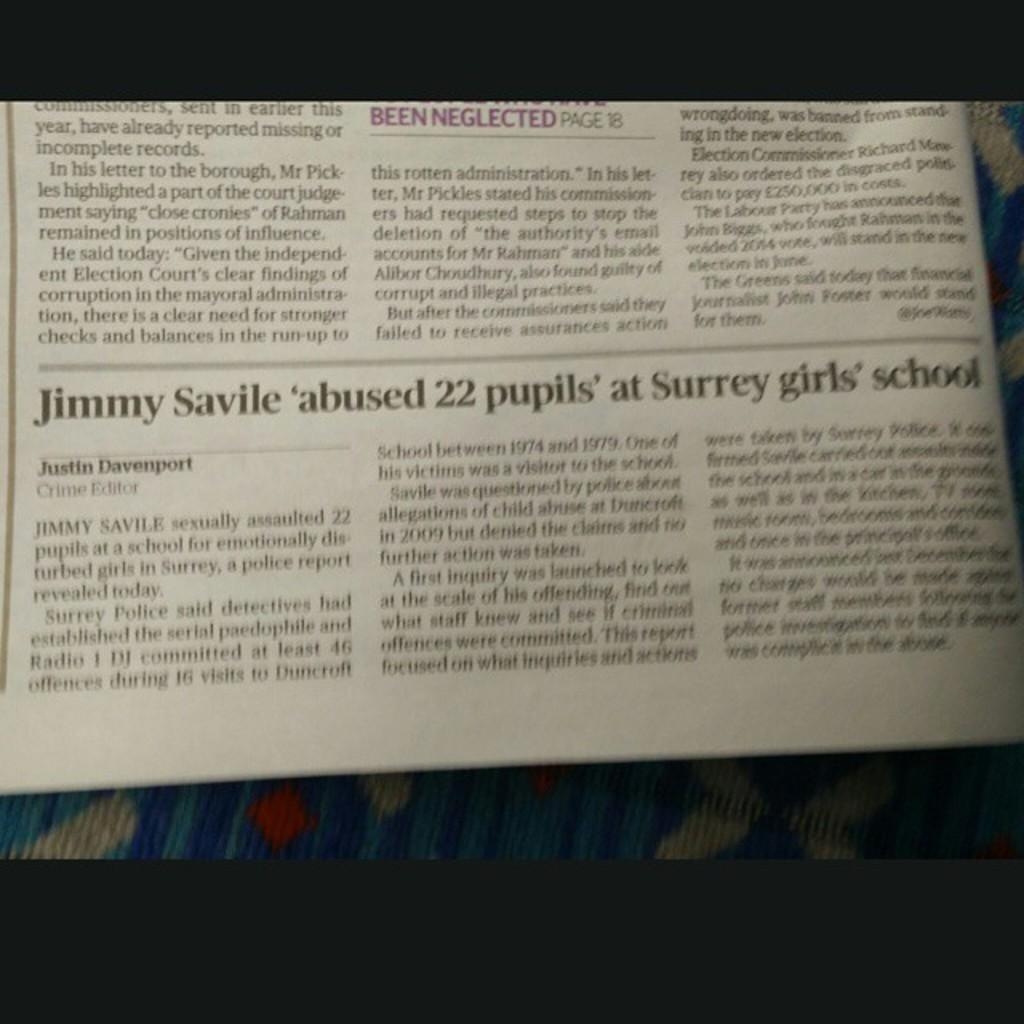Provide a one-sentence caption for the provided image. Newspaper about Jimmy Savile abused 22 pupils at Surrey girls school. 